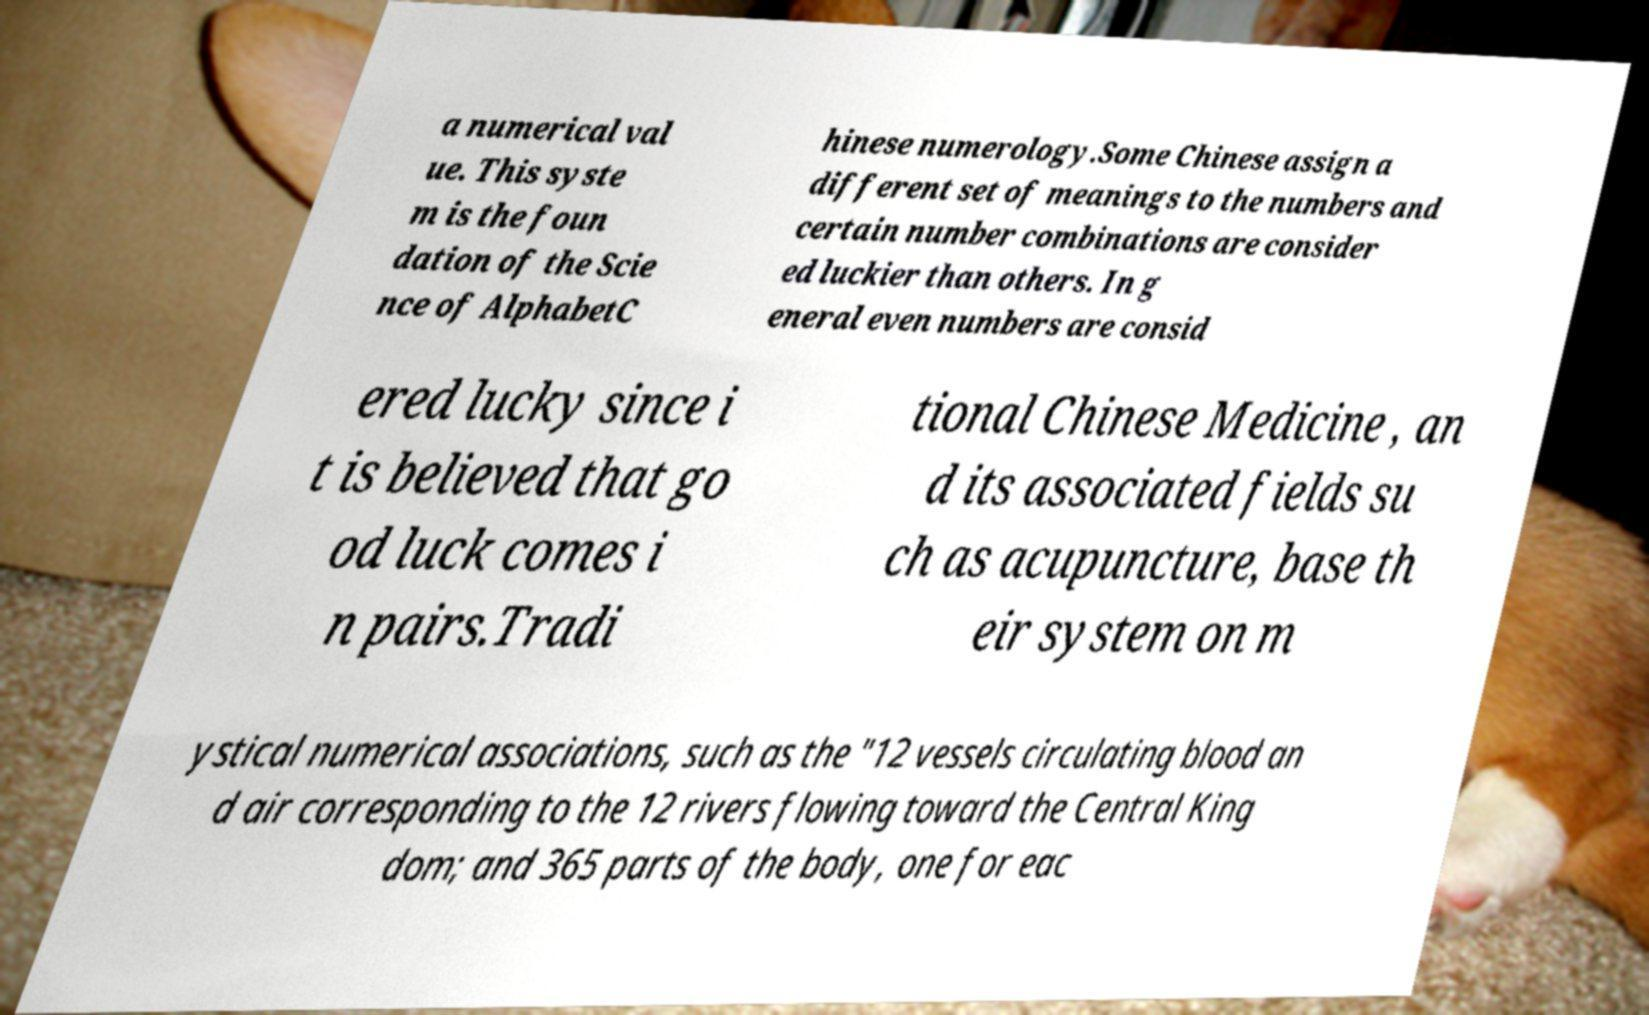I need the written content from this picture converted into text. Can you do that? a numerical val ue. This syste m is the foun dation of the Scie nce of AlphabetC hinese numerology.Some Chinese assign a different set of meanings to the numbers and certain number combinations are consider ed luckier than others. In g eneral even numbers are consid ered lucky since i t is believed that go od luck comes i n pairs.Tradi tional Chinese Medicine , an d its associated fields su ch as acupuncture, base th eir system on m ystical numerical associations, such as the "12 vessels circulating blood an d air corresponding to the 12 rivers flowing toward the Central King dom; and 365 parts of the body, one for eac 